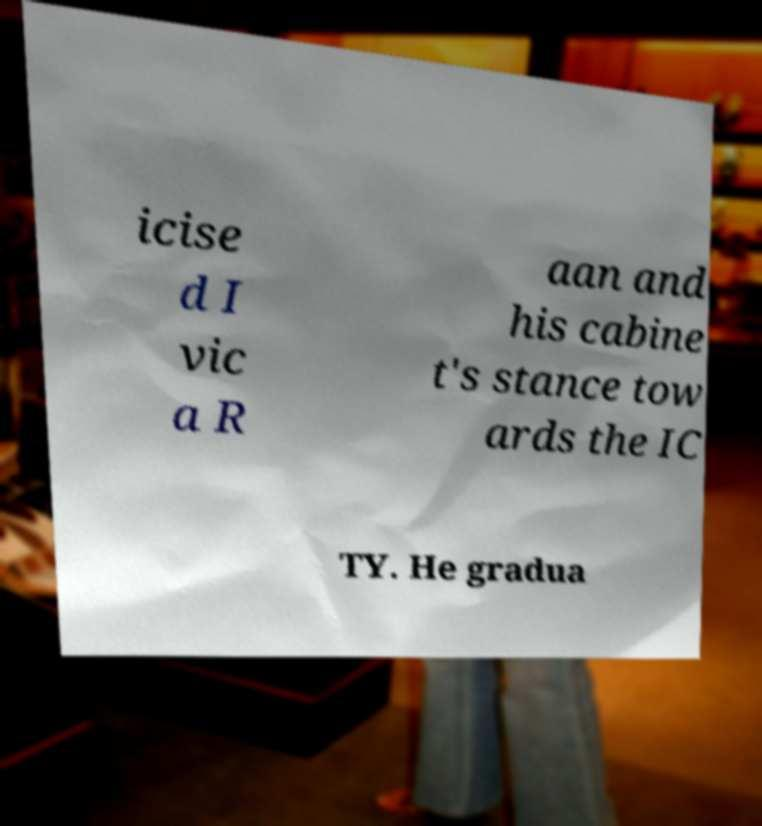Could you assist in decoding the text presented in this image and type it out clearly? icise d I vic a R aan and his cabine t's stance tow ards the IC TY. He gradua 